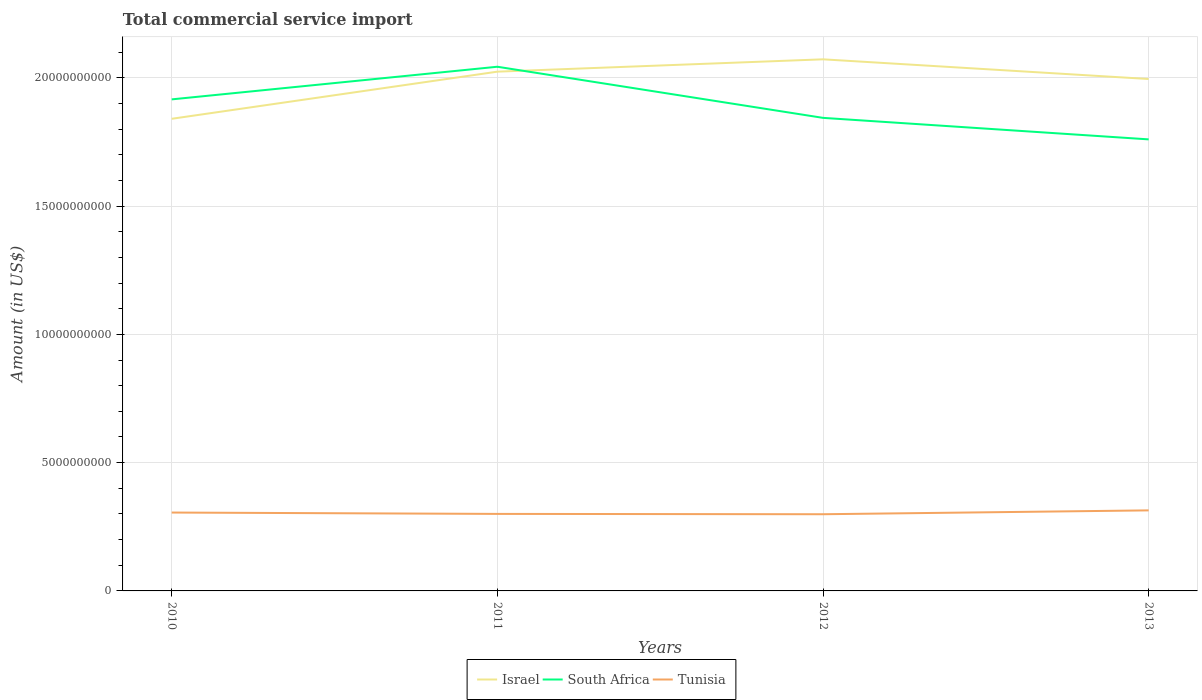Is the number of lines equal to the number of legend labels?
Make the answer very short. Yes. Across all years, what is the maximum total commercial service import in South Africa?
Give a very brief answer. 1.76e+1. What is the total total commercial service import in Tunisia in the graph?
Your response must be concise. 5.25e+07. What is the difference between the highest and the second highest total commercial service import in South Africa?
Make the answer very short. 2.83e+09. What is the difference between the highest and the lowest total commercial service import in South Africa?
Provide a short and direct response. 2. How many lines are there?
Offer a terse response. 3. How many years are there in the graph?
Keep it short and to the point. 4. Are the values on the major ticks of Y-axis written in scientific E-notation?
Offer a very short reply. No. Does the graph contain any zero values?
Provide a short and direct response. No. How many legend labels are there?
Keep it short and to the point. 3. How are the legend labels stacked?
Offer a terse response. Horizontal. What is the title of the graph?
Make the answer very short. Total commercial service import. What is the label or title of the X-axis?
Offer a very short reply. Years. What is the label or title of the Y-axis?
Keep it short and to the point. Amount (in US$). What is the Amount (in US$) in Israel in 2010?
Ensure brevity in your answer.  1.84e+1. What is the Amount (in US$) in South Africa in 2010?
Give a very brief answer. 1.92e+1. What is the Amount (in US$) of Tunisia in 2010?
Provide a succinct answer. 3.05e+09. What is the Amount (in US$) of Israel in 2011?
Provide a short and direct response. 2.02e+1. What is the Amount (in US$) in South Africa in 2011?
Provide a short and direct response. 2.04e+1. What is the Amount (in US$) in Tunisia in 2011?
Provide a short and direct response. 3.00e+09. What is the Amount (in US$) in Israel in 2012?
Your response must be concise. 2.07e+1. What is the Amount (in US$) in South Africa in 2012?
Keep it short and to the point. 1.84e+1. What is the Amount (in US$) in Tunisia in 2012?
Offer a very short reply. 2.99e+09. What is the Amount (in US$) in Israel in 2013?
Provide a short and direct response. 2.00e+1. What is the Amount (in US$) of South Africa in 2013?
Ensure brevity in your answer.  1.76e+1. What is the Amount (in US$) of Tunisia in 2013?
Provide a succinct answer. 3.14e+09. Across all years, what is the maximum Amount (in US$) of Israel?
Provide a succinct answer. 2.07e+1. Across all years, what is the maximum Amount (in US$) of South Africa?
Provide a succinct answer. 2.04e+1. Across all years, what is the maximum Amount (in US$) in Tunisia?
Your answer should be very brief. 3.14e+09. Across all years, what is the minimum Amount (in US$) of Israel?
Your answer should be very brief. 1.84e+1. Across all years, what is the minimum Amount (in US$) in South Africa?
Offer a terse response. 1.76e+1. Across all years, what is the minimum Amount (in US$) of Tunisia?
Provide a short and direct response. 2.99e+09. What is the total Amount (in US$) in Israel in the graph?
Offer a very short reply. 7.93e+1. What is the total Amount (in US$) of South Africa in the graph?
Provide a succinct answer. 7.56e+1. What is the total Amount (in US$) of Tunisia in the graph?
Offer a terse response. 1.22e+1. What is the difference between the Amount (in US$) in Israel in 2010 and that in 2011?
Provide a short and direct response. -1.84e+09. What is the difference between the Amount (in US$) in South Africa in 2010 and that in 2011?
Your answer should be very brief. -1.27e+09. What is the difference between the Amount (in US$) of Tunisia in 2010 and that in 2011?
Offer a very short reply. 5.25e+07. What is the difference between the Amount (in US$) of Israel in 2010 and that in 2012?
Ensure brevity in your answer.  -2.32e+09. What is the difference between the Amount (in US$) of South Africa in 2010 and that in 2012?
Keep it short and to the point. 7.21e+08. What is the difference between the Amount (in US$) of Tunisia in 2010 and that in 2012?
Provide a succinct answer. 6.57e+07. What is the difference between the Amount (in US$) in Israel in 2010 and that in 2013?
Your response must be concise. -1.55e+09. What is the difference between the Amount (in US$) of South Africa in 2010 and that in 2013?
Your answer should be compact. 1.56e+09. What is the difference between the Amount (in US$) of Tunisia in 2010 and that in 2013?
Make the answer very short. -8.51e+07. What is the difference between the Amount (in US$) in Israel in 2011 and that in 2012?
Offer a very short reply. -4.81e+08. What is the difference between the Amount (in US$) in South Africa in 2011 and that in 2012?
Ensure brevity in your answer.  1.99e+09. What is the difference between the Amount (in US$) of Tunisia in 2011 and that in 2012?
Your response must be concise. 1.32e+07. What is the difference between the Amount (in US$) in Israel in 2011 and that in 2013?
Make the answer very short. 2.86e+08. What is the difference between the Amount (in US$) in South Africa in 2011 and that in 2013?
Offer a terse response. 2.83e+09. What is the difference between the Amount (in US$) of Tunisia in 2011 and that in 2013?
Provide a short and direct response. -1.38e+08. What is the difference between the Amount (in US$) in Israel in 2012 and that in 2013?
Give a very brief answer. 7.67e+08. What is the difference between the Amount (in US$) of South Africa in 2012 and that in 2013?
Provide a short and direct response. 8.38e+08. What is the difference between the Amount (in US$) in Tunisia in 2012 and that in 2013?
Give a very brief answer. -1.51e+08. What is the difference between the Amount (in US$) of Israel in 2010 and the Amount (in US$) of South Africa in 2011?
Ensure brevity in your answer.  -2.03e+09. What is the difference between the Amount (in US$) of Israel in 2010 and the Amount (in US$) of Tunisia in 2011?
Your answer should be very brief. 1.54e+1. What is the difference between the Amount (in US$) of South Africa in 2010 and the Amount (in US$) of Tunisia in 2011?
Your response must be concise. 1.62e+1. What is the difference between the Amount (in US$) of Israel in 2010 and the Amount (in US$) of South Africa in 2012?
Ensure brevity in your answer.  -3.63e+07. What is the difference between the Amount (in US$) of Israel in 2010 and the Amount (in US$) of Tunisia in 2012?
Give a very brief answer. 1.54e+1. What is the difference between the Amount (in US$) of South Africa in 2010 and the Amount (in US$) of Tunisia in 2012?
Your answer should be very brief. 1.62e+1. What is the difference between the Amount (in US$) of Israel in 2010 and the Amount (in US$) of South Africa in 2013?
Ensure brevity in your answer.  8.02e+08. What is the difference between the Amount (in US$) of Israel in 2010 and the Amount (in US$) of Tunisia in 2013?
Provide a succinct answer. 1.53e+1. What is the difference between the Amount (in US$) of South Africa in 2010 and the Amount (in US$) of Tunisia in 2013?
Provide a short and direct response. 1.60e+1. What is the difference between the Amount (in US$) of Israel in 2011 and the Amount (in US$) of South Africa in 2012?
Offer a very short reply. 1.80e+09. What is the difference between the Amount (in US$) in Israel in 2011 and the Amount (in US$) in Tunisia in 2012?
Give a very brief answer. 1.72e+1. What is the difference between the Amount (in US$) in South Africa in 2011 and the Amount (in US$) in Tunisia in 2012?
Your response must be concise. 1.74e+1. What is the difference between the Amount (in US$) in Israel in 2011 and the Amount (in US$) in South Africa in 2013?
Provide a succinct answer. 2.64e+09. What is the difference between the Amount (in US$) in Israel in 2011 and the Amount (in US$) in Tunisia in 2013?
Your answer should be compact. 1.71e+1. What is the difference between the Amount (in US$) in South Africa in 2011 and the Amount (in US$) in Tunisia in 2013?
Provide a succinct answer. 1.73e+1. What is the difference between the Amount (in US$) of Israel in 2012 and the Amount (in US$) of South Africa in 2013?
Your answer should be very brief. 3.12e+09. What is the difference between the Amount (in US$) of Israel in 2012 and the Amount (in US$) of Tunisia in 2013?
Ensure brevity in your answer.  1.76e+1. What is the difference between the Amount (in US$) in South Africa in 2012 and the Amount (in US$) in Tunisia in 2013?
Keep it short and to the point. 1.53e+1. What is the average Amount (in US$) in Israel per year?
Offer a very short reply. 1.98e+1. What is the average Amount (in US$) of South Africa per year?
Give a very brief answer. 1.89e+1. What is the average Amount (in US$) in Tunisia per year?
Your answer should be compact. 3.05e+09. In the year 2010, what is the difference between the Amount (in US$) of Israel and Amount (in US$) of South Africa?
Ensure brevity in your answer.  -7.57e+08. In the year 2010, what is the difference between the Amount (in US$) of Israel and Amount (in US$) of Tunisia?
Give a very brief answer. 1.53e+1. In the year 2010, what is the difference between the Amount (in US$) in South Africa and Amount (in US$) in Tunisia?
Your response must be concise. 1.61e+1. In the year 2011, what is the difference between the Amount (in US$) of Israel and Amount (in US$) of South Africa?
Offer a terse response. -1.92e+08. In the year 2011, what is the difference between the Amount (in US$) of Israel and Amount (in US$) of Tunisia?
Offer a terse response. 1.72e+1. In the year 2011, what is the difference between the Amount (in US$) in South Africa and Amount (in US$) in Tunisia?
Your response must be concise. 1.74e+1. In the year 2012, what is the difference between the Amount (in US$) of Israel and Amount (in US$) of South Africa?
Your response must be concise. 2.28e+09. In the year 2012, what is the difference between the Amount (in US$) in Israel and Amount (in US$) in Tunisia?
Provide a succinct answer. 1.77e+1. In the year 2012, what is the difference between the Amount (in US$) in South Africa and Amount (in US$) in Tunisia?
Offer a very short reply. 1.54e+1. In the year 2013, what is the difference between the Amount (in US$) in Israel and Amount (in US$) in South Africa?
Provide a succinct answer. 2.35e+09. In the year 2013, what is the difference between the Amount (in US$) in Israel and Amount (in US$) in Tunisia?
Ensure brevity in your answer.  1.68e+1. In the year 2013, what is the difference between the Amount (in US$) in South Africa and Amount (in US$) in Tunisia?
Your answer should be very brief. 1.45e+1. What is the ratio of the Amount (in US$) in Israel in 2010 to that in 2011?
Keep it short and to the point. 0.91. What is the ratio of the Amount (in US$) of South Africa in 2010 to that in 2011?
Provide a succinct answer. 0.94. What is the ratio of the Amount (in US$) of Tunisia in 2010 to that in 2011?
Offer a terse response. 1.02. What is the ratio of the Amount (in US$) of Israel in 2010 to that in 2012?
Your answer should be compact. 0.89. What is the ratio of the Amount (in US$) of South Africa in 2010 to that in 2012?
Your answer should be compact. 1.04. What is the ratio of the Amount (in US$) of Israel in 2010 to that in 2013?
Make the answer very short. 0.92. What is the ratio of the Amount (in US$) of South Africa in 2010 to that in 2013?
Your response must be concise. 1.09. What is the ratio of the Amount (in US$) in Tunisia in 2010 to that in 2013?
Provide a succinct answer. 0.97. What is the ratio of the Amount (in US$) of Israel in 2011 to that in 2012?
Your answer should be compact. 0.98. What is the ratio of the Amount (in US$) in South Africa in 2011 to that in 2012?
Provide a short and direct response. 1.11. What is the ratio of the Amount (in US$) in Israel in 2011 to that in 2013?
Provide a short and direct response. 1.01. What is the ratio of the Amount (in US$) in South Africa in 2011 to that in 2013?
Make the answer very short. 1.16. What is the ratio of the Amount (in US$) in Tunisia in 2011 to that in 2013?
Make the answer very short. 0.96. What is the ratio of the Amount (in US$) in Israel in 2012 to that in 2013?
Provide a short and direct response. 1.04. What is the ratio of the Amount (in US$) of South Africa in 2012 to that in 2013?
Keep it short and to the point. 1.05. What is the ratio of the Amount (in US$) of Tunisia in 2012 to that in 2013?
Provide a succinct answer. 0.95. What is the difference between the highest and the second highest Amount (in US$) of Israel?
Make the answer very short. 4.81e+08. What is the difference between the highest and the second highest Amount (in US$) of South Africa?
Offer a terse response. 1.27e+09. What is the difference between the highest and the second highest Amount (in US$) of Tunisia?
Provide a succinct answer. 8.51e+07. What is the difference between the highest and the lowest Amount (in US$) in Israel?
Provide a succinct answer. 2.32e+09. What is the difference between the highest and the lowest Amount (in US$) of South Africa?
Offer a terse response. 2.83e+09. What is the difference between the highest and the lowest Amount (in US$) of Tunisia?
Give a very brief answer. 1.51e+08. 